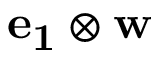<formula> <loc_0><loc_0><loc_500><loc_500>e _ { 1 } \otimes w</formula> 